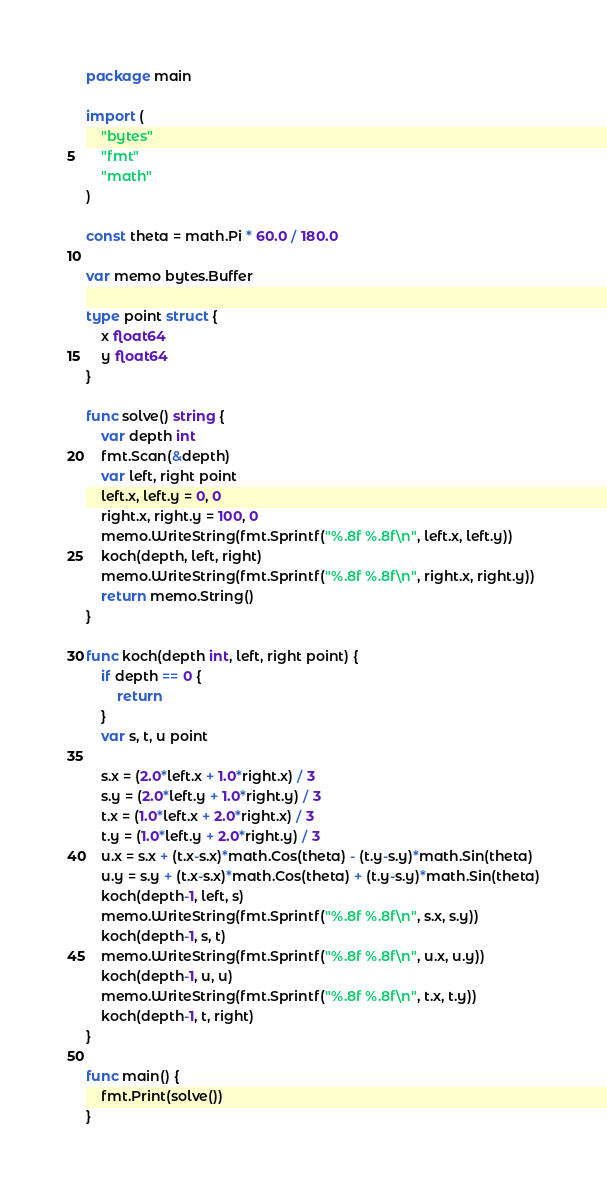<code> <loc_0><loc_0><loc_500><loc_500><_Go_>package main

import (
	"bytes"
	"fmt"
	"math"
)

const theta = math.Pi * 60.0 / 180.0

var memo bytes.Buffer

type point struct {
	x float64
	y float64
}

func solve() string {
	var depth int
	fmt.Scan(&depth)
	var left, right point
	left.x, left.y = 0, 0
	right.x, right.y = 100, 0
	memo.WriteString(fmt.Sprintf("%.8f %.8f\n", left.x, left.y))
	koch(depth, left, right)
	memo.WriteString(fmt.Sprintf("%.8f %.8f\n", right.x, right.y))
	return memo.String()
}

func koch(depth int, left, right point) {
	if depth == 0 {
		return
	}
	var s, t, u point

	s.x = (2.0*left.x + 1.0*right.x) / 3
	s.y = (2.0*left.y + 1.0*right.y) / 3
	t.x = (1.0*left.x + 2.0*right.x) / 3
	t.y = (1.0*left.y + 2.0*right.y) / 3
	u.x = s.x + (t.x-s.x)*math.Cos(theta) - (t.y-s.y)*math.Sin(theta)
	u.y = s.y + (t.x-s.x)*math.Cos(theta) + (t.y-s.y)*math.Sin(theta)
	koch(depth-1, left, s)
	memo.WriteString(fmt.Sprintf("%.8f %.8f\n", s.x, s.y))
	koch(depth-1, s, t)
	memo.WriteString(fmt.Sprintf("%.8f %.8f\n", u.x, u.y))
	koch(depth-1, u, u)
	memo.WriteString(fmt.Sprintf("%.8f %.8f\n", t.x, t.y))
	koch(depth-1, t, right)
}

func main() {
	fmt.Print(solve())
}

</code> 